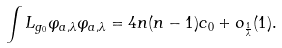<formula> <loc_0><loc_0><loc_500><loc_500>\int L _ { g _ { 0 } } \varphi _ { a , \lambda } \varphi _ { a , \lambda } = 4 n ( n - 1 ) c _ { 0 } + o _ { \frac { 1 } { \lambda } } ( 1 ) .</formula> 